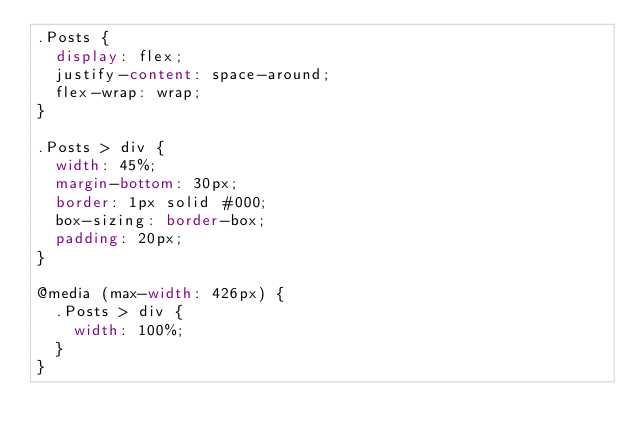Convert code to text. <code><loc_0><loc_0><loc_500><loc_500><_CSS_>.Posts {
  display: flex;
  justify-content: space-around;
  flex-wrap: wrap;
}

.Posts > div {
  width: 45%;
  margin-bottom: 30px;
  border: 1px solid #000;
  box-sizing: border-box;
  padding: 20px;
}

@media (max-width: 426px) {
  .Posts > div {
    width: 100%;
  }
}
</code> 